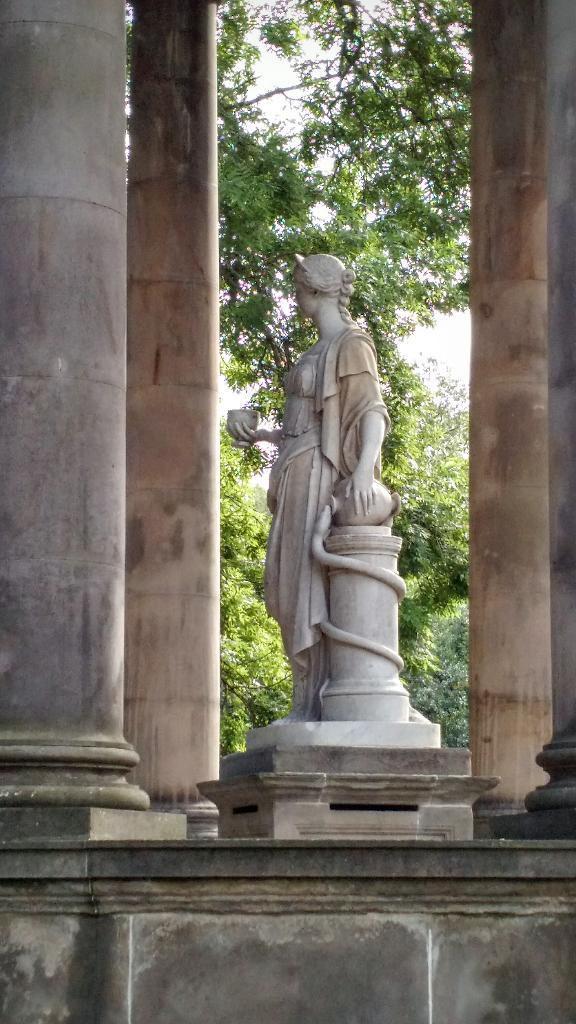What is the main subject of the image? There is a statue in the image. What architectural elements can be seen in the image? There are pillars in the image. What type of vegetation is present in the image? There are trees in the image. What is visible in the background of the image? The sky is visible in the image. How many rings are visible on the statue's fingers in the image? There are no rings visible on the statue's fingers in the image, as the statue is not depicted as having fingers or wearing rings. 